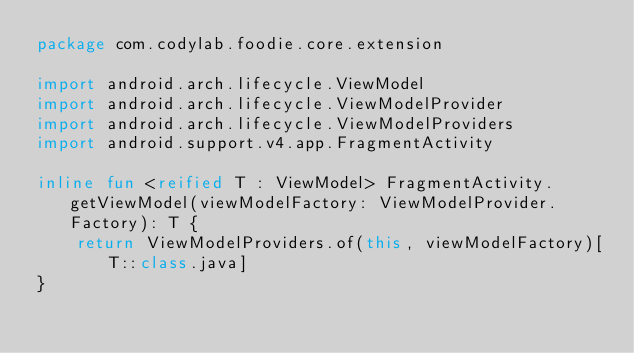Convert code to text. <code><loc_0><loc_0><loc_500><loc_500><_Kotlin_>package com.codylab.foodie.core.extension

import android.arch.lifecycle.ViewModel
import android.arch.lifecycle.ViewModelProvider
import android.arch.lifecycle.ViewModelProviders
import android.support.v4.app.FragmentActivity

inline fun <reified T : ViewModel> FragmentActivity.getViewModel(viewModelFactory: ViewModelProvider.Factory): T {
    return ViewModelProviders.of(this, viewModelFactory)[T::class.java]
}
</code> 